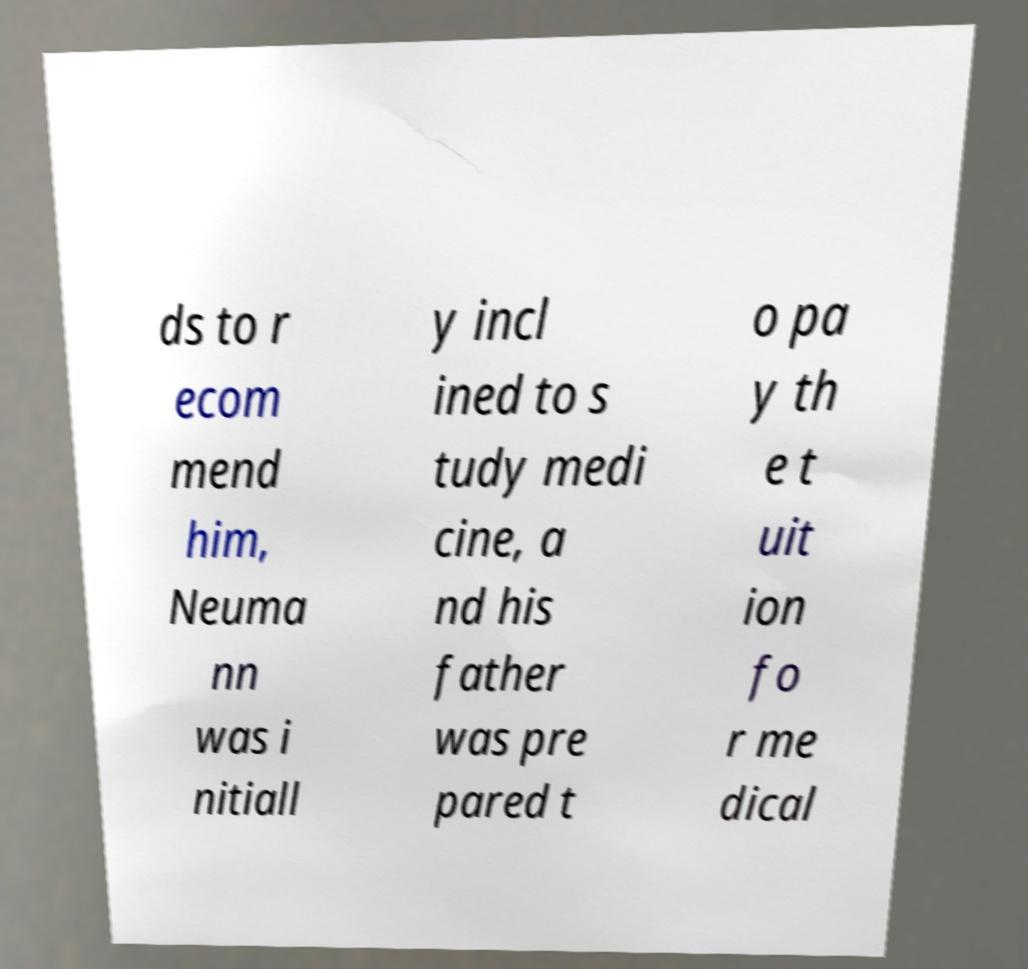What messages or text are displayed in this image? I need them in a readable, typed format. ds to r ecom mend him, Neuma nn was i nitiall y incl ined to s tudy medi cine, a nd his father was pre pared t o pa y th e t uit ion fo r me dical 